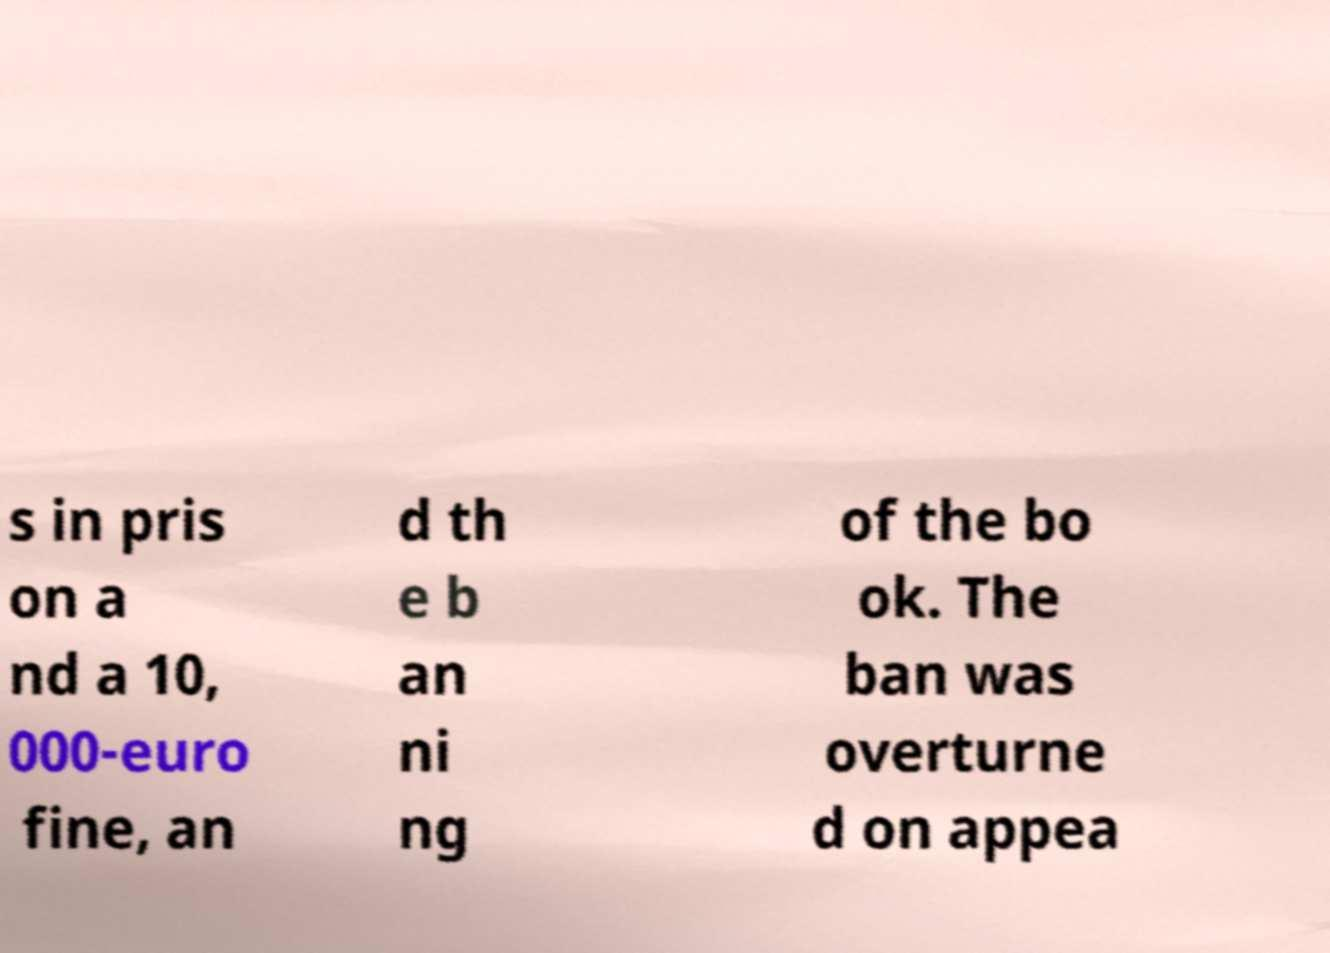There's text embedded in this image that I need extracted. Can you transcribe it verbatim? s in pris on a nd a 10, 000-euro fine, an d th e b an ni ng of the bo ok. The ban was overturne d on appea 